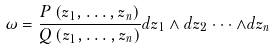Convert formula to latex. <formula><loc_0><loc_0><loc_500><loc_500>\omega = \frac { P \left ( z _ { 1 } , \dots , z _ { n } \right ) } { Q \left ( z _ { 1 } , \dots , z _ { n } \right ) } d z _ { 1 } \wedge d z _ { 2 } \cdot \cdot \cdot \wedge d z _ { n }</formula> 